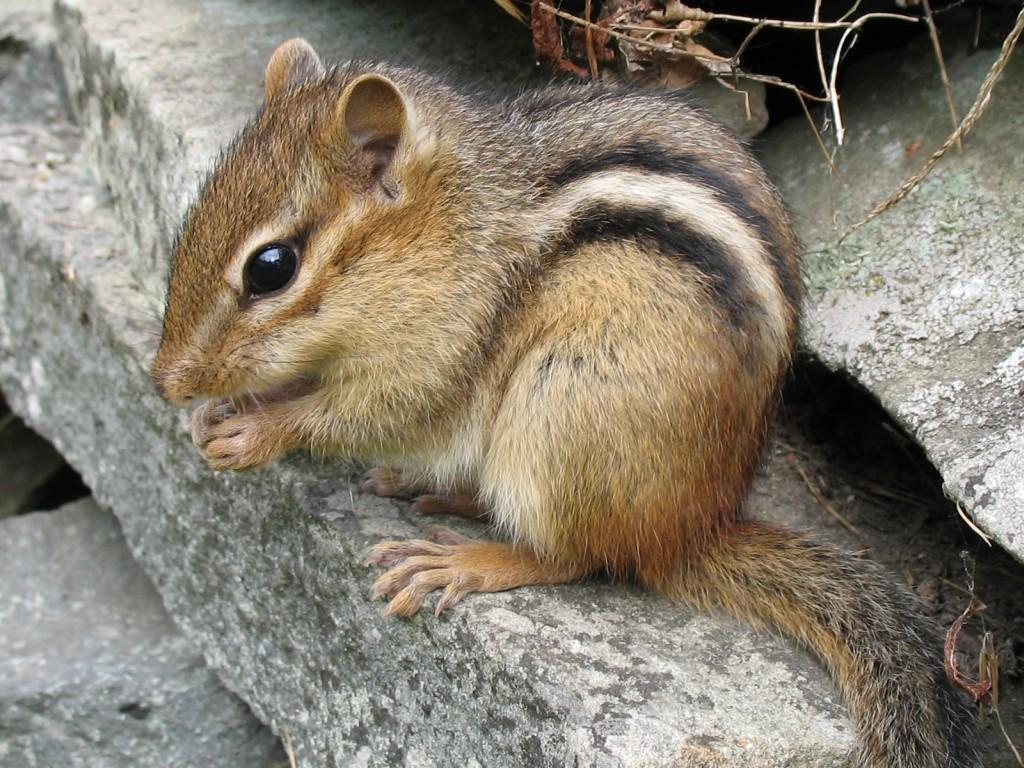Can you describe this image briefly? This is a squirrel, which is on the rock. At the top of the image, I think these look like the stems, which are dried. 